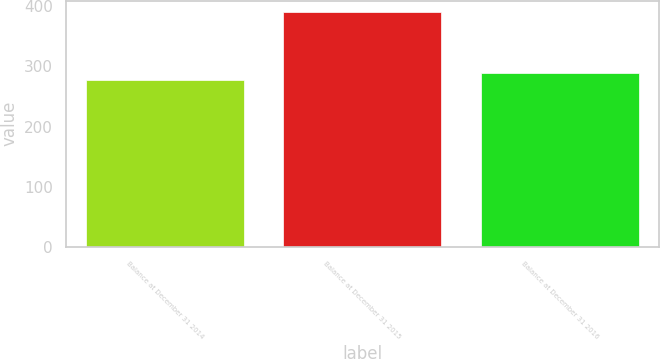Convert chart. <chart><loc_0><loc_0><loc_500><loc_500><bar_chart><fcel>Balance at December 31 2014<fcel>Balance at December 31 2015<fcel>Balance at December 31 2016<nl><fcel>277<fcel>390<fcel>288.3<nl></chart> 